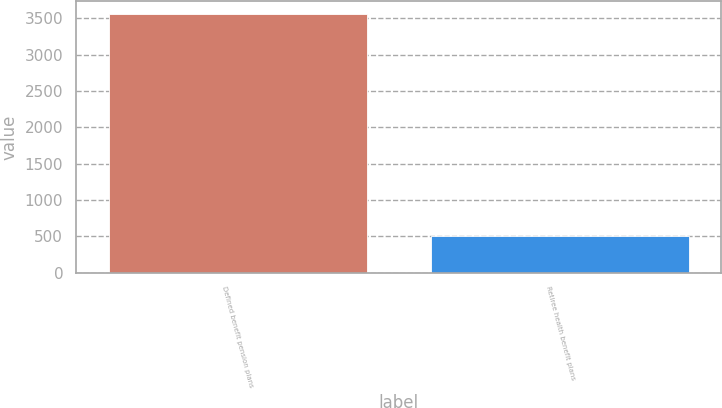<chart> <loc_0><loc_0><loc_500><loc_500><bar_chart><fcel>Defined benefit pension plans<fcel>Retiree health benefit plans<nl><fcel>3560.6<fcel>505.3<nl></chart> 